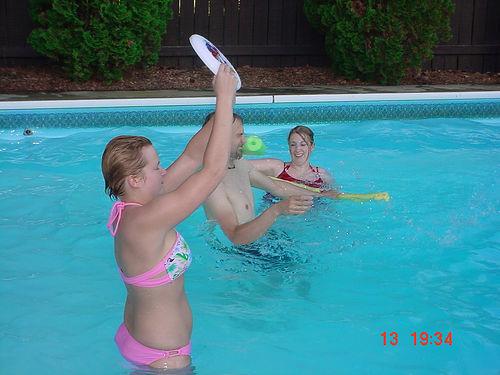Where is the pool?
Answer briefly. On ground. How many women are in the pool?
Answer briefly. 2. What does the 13 stand for?
Answer briefly. Date. 